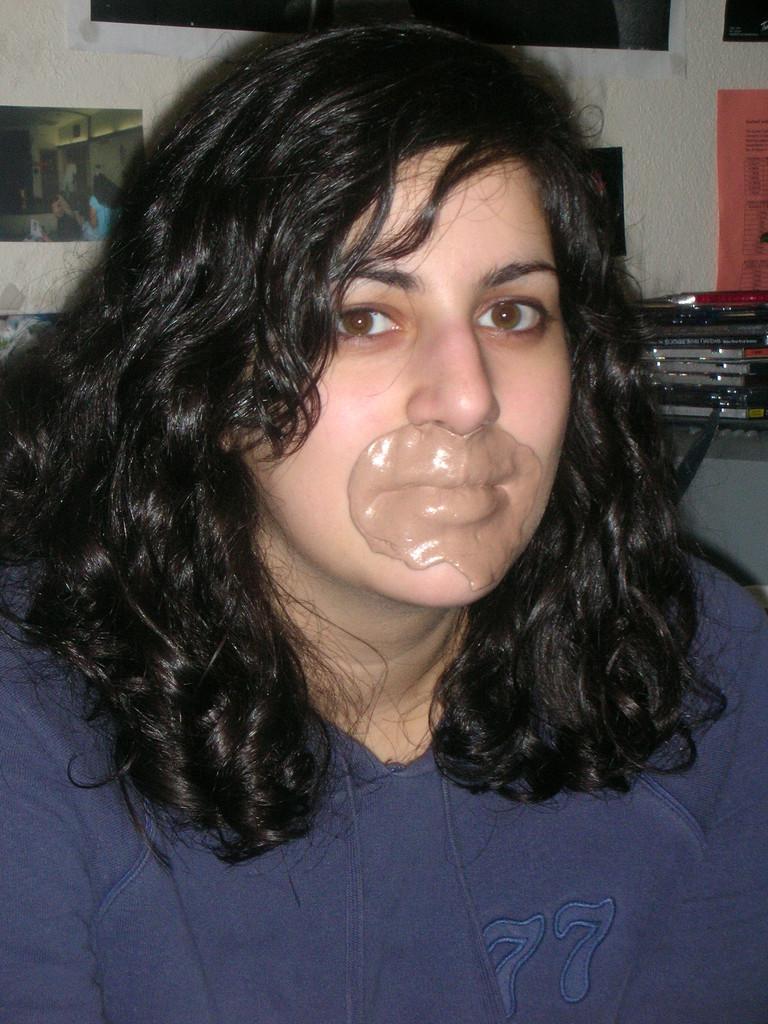In one or two sentences, can you explain what this image depicts? In this picture I can see a woman in front and I see that she is wearing blue color top and I see cream on her mouth. In the background I can see the wall on which there are few photos and on the right side of this picture I can see few things. 